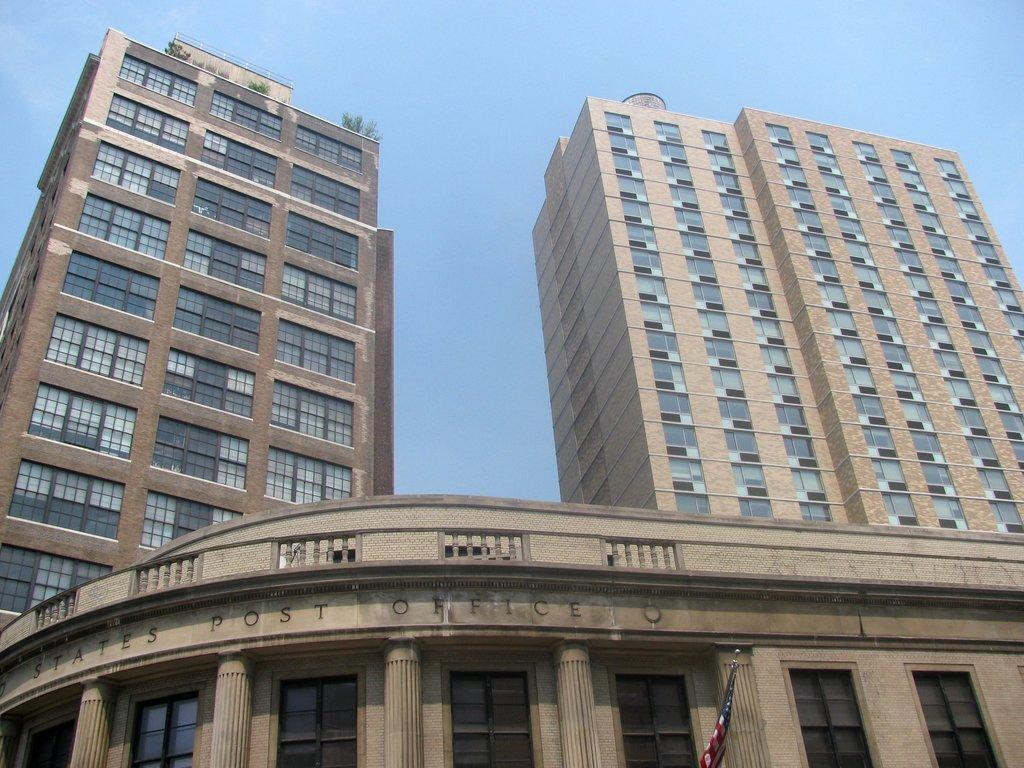Could you give a brief overview of what you see in this image? In this picture we can see some buildings. There are few plants on this building on the left side. We can see a flag. 